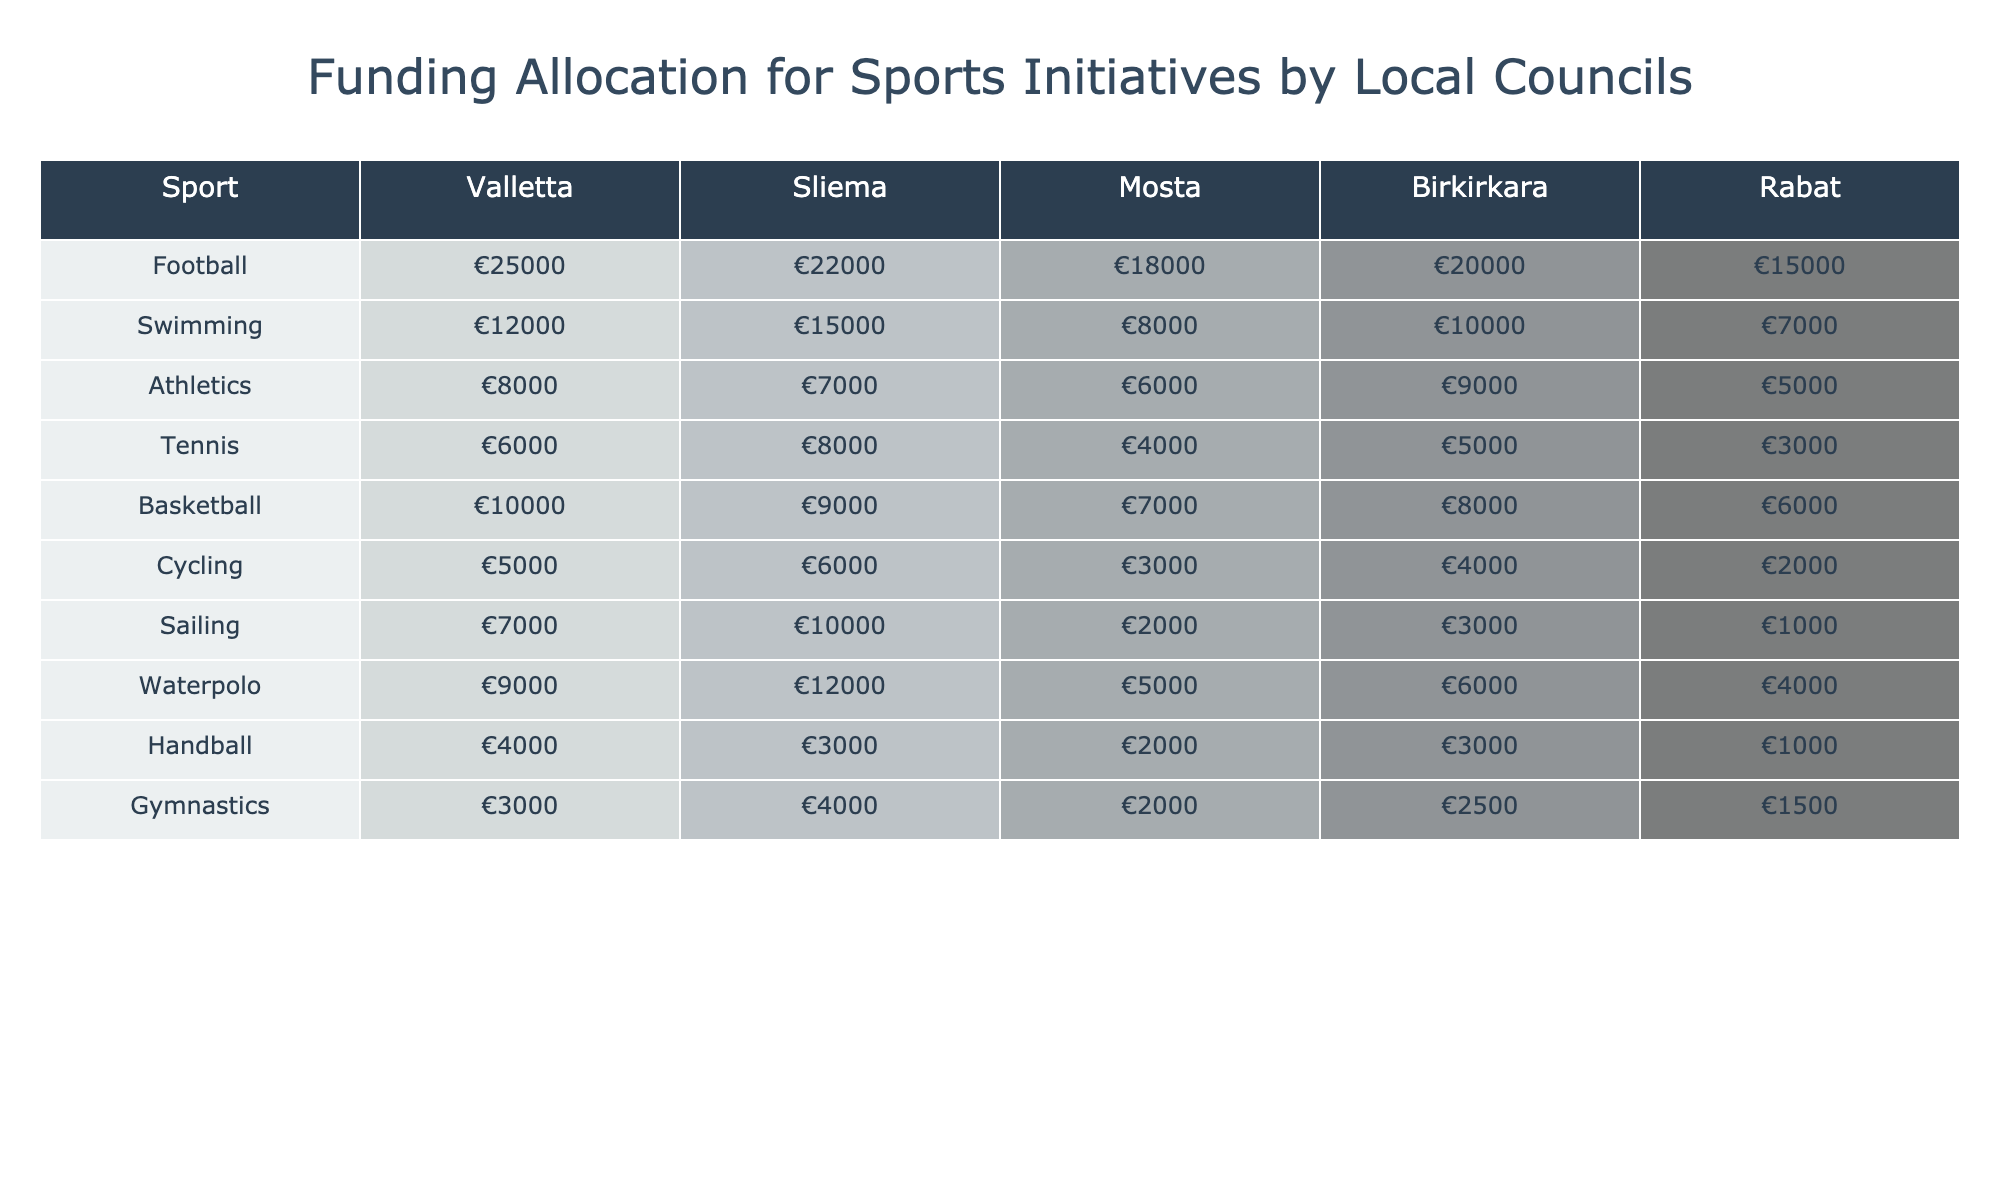What is the total funding allocated for football in all councils? The funding amounts for football in the councils are €25,000 (Valletta), €22,000 (Sliema), €18,000 (Mosta), €20,000 (Birkirkara), and €15,000 (Rabat). Adding these values gives: 25,000 + 22,000 + 18,000 + 20,000 + 15,000 = €100,000.
Answer: €100,000 Which sport received the highest funding from Rabat? Looking at the funding values for Rabat, the amounts are: €15,000 for football, €7,000 for swimming, €5,000 for athletics, €5,000 for tennis, €6,000 for basketball, €2,000 for cycling, €1,000 for sailing, €4,000 for waterpolo, €1,000 for handball, and €1,500 for gymnastics. The highest funding is €15,000 for football.
Answer: Football Is the total funding for swimming in Valletta greater than that in Mosta? In Valletta, the funding for swimming is €12,000 and in Mosta, it's €8,000. Since €12,000 is greater than €8,000, the statement is true.
Answer: Yes What is the average funding allocation for all sports in Sliema? First, list the funding amounts in Sliema: €22,000 (football), €15,000 (swimming), €7,000 (athletics), €8,000 (tennis), €9,000 (basketball), €6,000 (cycling), €10,000 (sailing), €12,000 (waterpolo), €3,000 (handball), €4,000 (gymnastics). Adding these gives: 22,000 + 15,000 + 7,000 + 8,000 + 9,000 + 6,000 + 10,000 + 12,000 + 3,000 + 4,000 = €96,000. There are 10 sports, so the average is 96,000 / 10 = €9,600.
Answer: €9,600 Which sport has the lowest overall funding across all councils? By inspecting the funding values across all sports: Football (€100,000), Swimming (€52,000), Athletics (€37,000), Tennis (€28,000), Basketball (€37,000), Cycling (€20,000), Sailing (€13,000), Waterpolo (€34,000), Handball (€10,000), and Gymnastics (€15,000). The lowest is €10,000 for handball.
Answer: Handball What is the difference in funding for basketball between Valletta and Rabat? The funding for basketball in Valletta is €10,000 and in Rabat it is €6,000. The difference is calculated as €10,000 - €6,000 = €4,000.
Answer: €4,000 Did cycling receive more funding in Sliema than in Rabat? The funding for cycling is €6,000 in Sliema and €2,000 in Rabat. Since €6,000 is greater than €2,000, the statement is true.
Answer: Yes Calculate the total funding for athletics from all councils. The funding for athletics is: €8,000 (Valletta), €7,000 (Sliema), €6,000 (Mosta), €9,000 (Birkirkara), and €5,000 (Rabat). Summing these values gives: 8,000 + 7,000 + 6,000 + 9,000 + 5,000 = €35,000.
Answer: €35,000 What percentage of the total funding for tennis is allocated by Valletta? The funding for tennis is €6,000 in Valletta and the total funding for tennis is: €6,000 (Valletta) + €8,000 (Sliema) + €4,000 (Mosta) + €5,000 (Birkirkara) + €3,000 (Rabat) = €26,000. The percentage from Valletta is (6,000 / 26,000) * 100 = 23.08%.
Answer: 23.08% Which council shows the most consistent funding across various sports? To determine consistency, we look for the council with the least difference between its highest and lowest funding amounts. The highest and lowest funding in each council is: Valletta (25000 - 3000), Sliema (15000 - 6000), Mosta (18000 - 6000), Birkirkara (20000 - 2500), Rabat (15000 - 1000). The smallest range is in Rabat (15,000 - 1,000 = 14,000). Most consistent: Rabat.
Answer: Rabat 